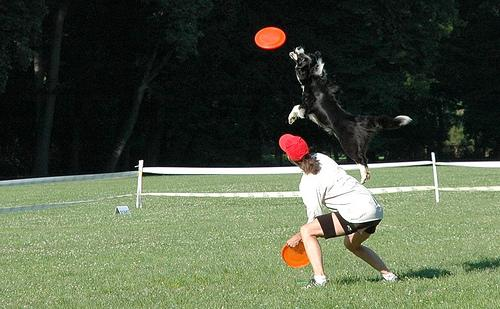What is the dog ready to do?

Choices:
A) roll over
B) ride
C) catch
D) walk catch 